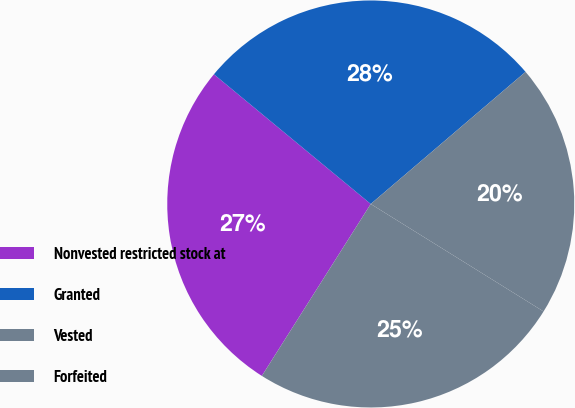Convert chart. <chart><loc_0><loc_0><loc_500><loc_500><pie_chart><fcel>Nonvested restricted stock at<fcel>Granted<fcel>Vested<fcel>Forfeited<nl><fcel>27.01%<fcel>27.76%<fcel>20.1%<fcel>25.13%<nl></chart> 